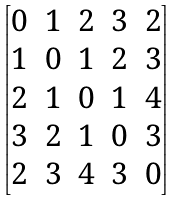Convert formula to latex. <formula><loc_0><loc_0><loc_500><loc_500>\begin{bmatrix} 0 & 1 & 2 & 3 & 2 \\ 1 & 0 & 1 & 2 & 3 \\ 2 & 1 & 0 & 1 & 4 \\ 3 & 2 & 1 & 0 & 3 \\ 2 & 3 & 4 & 3 & 0 \\ \end{bmatrix}</formula> 